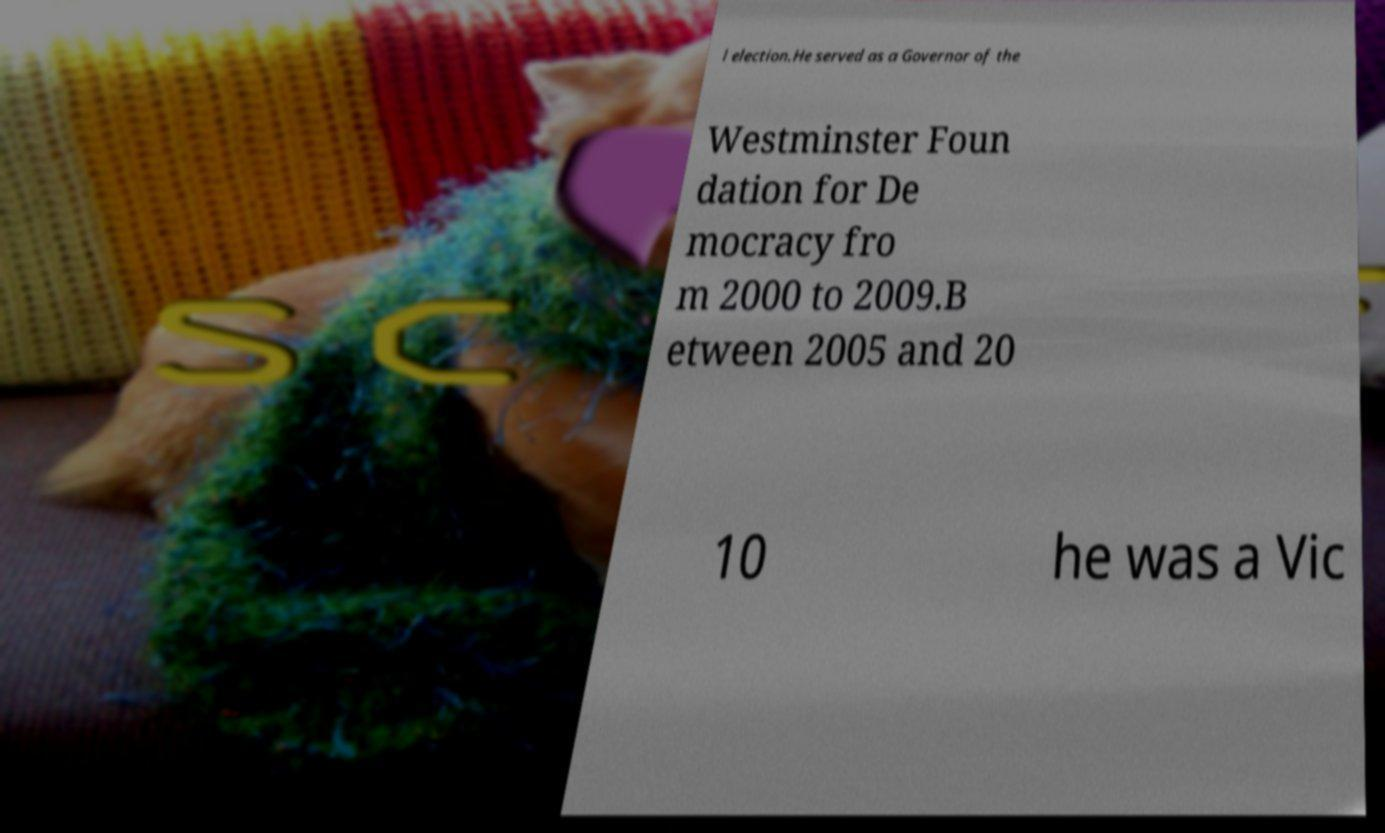What messages or text are displayed in this image? I need them in a readable, typed format. l election.He served as a Governor of the Westminster Foun dation for De mocracy fro m 2000 to 2009.B etween 2005 and 20 10 he was a Vic 